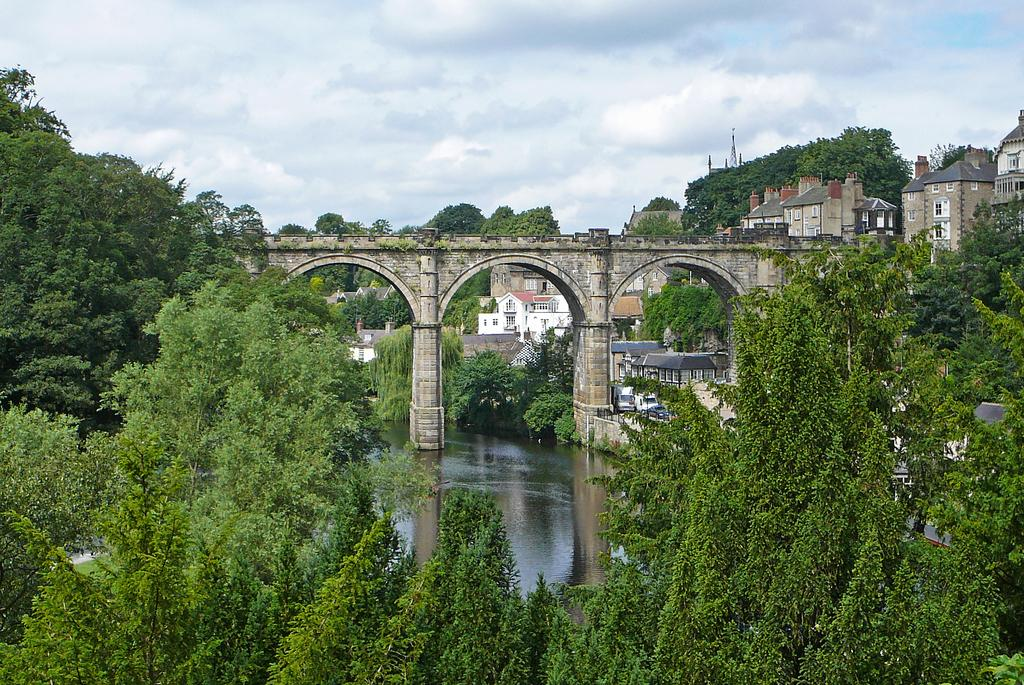What type of structures can be seen in the image? There are buildings in the image. What natural elements are present in the image? There are trees in the image. How would you describe the weather in the image? The sky is cloudy in the image. What type of man-made structure can be seen in the image? There is a bridge in the image. What type of transportation is visible in the image? There are vehicles in the image. What body of water can be seen in the image? There is water visible in the image. What type of string is being used by the spy in the image? There is no string or spy present in the image. What type of powder is being used to create the clouds in the image? The clouds in the image are natural and not created by any powder. 